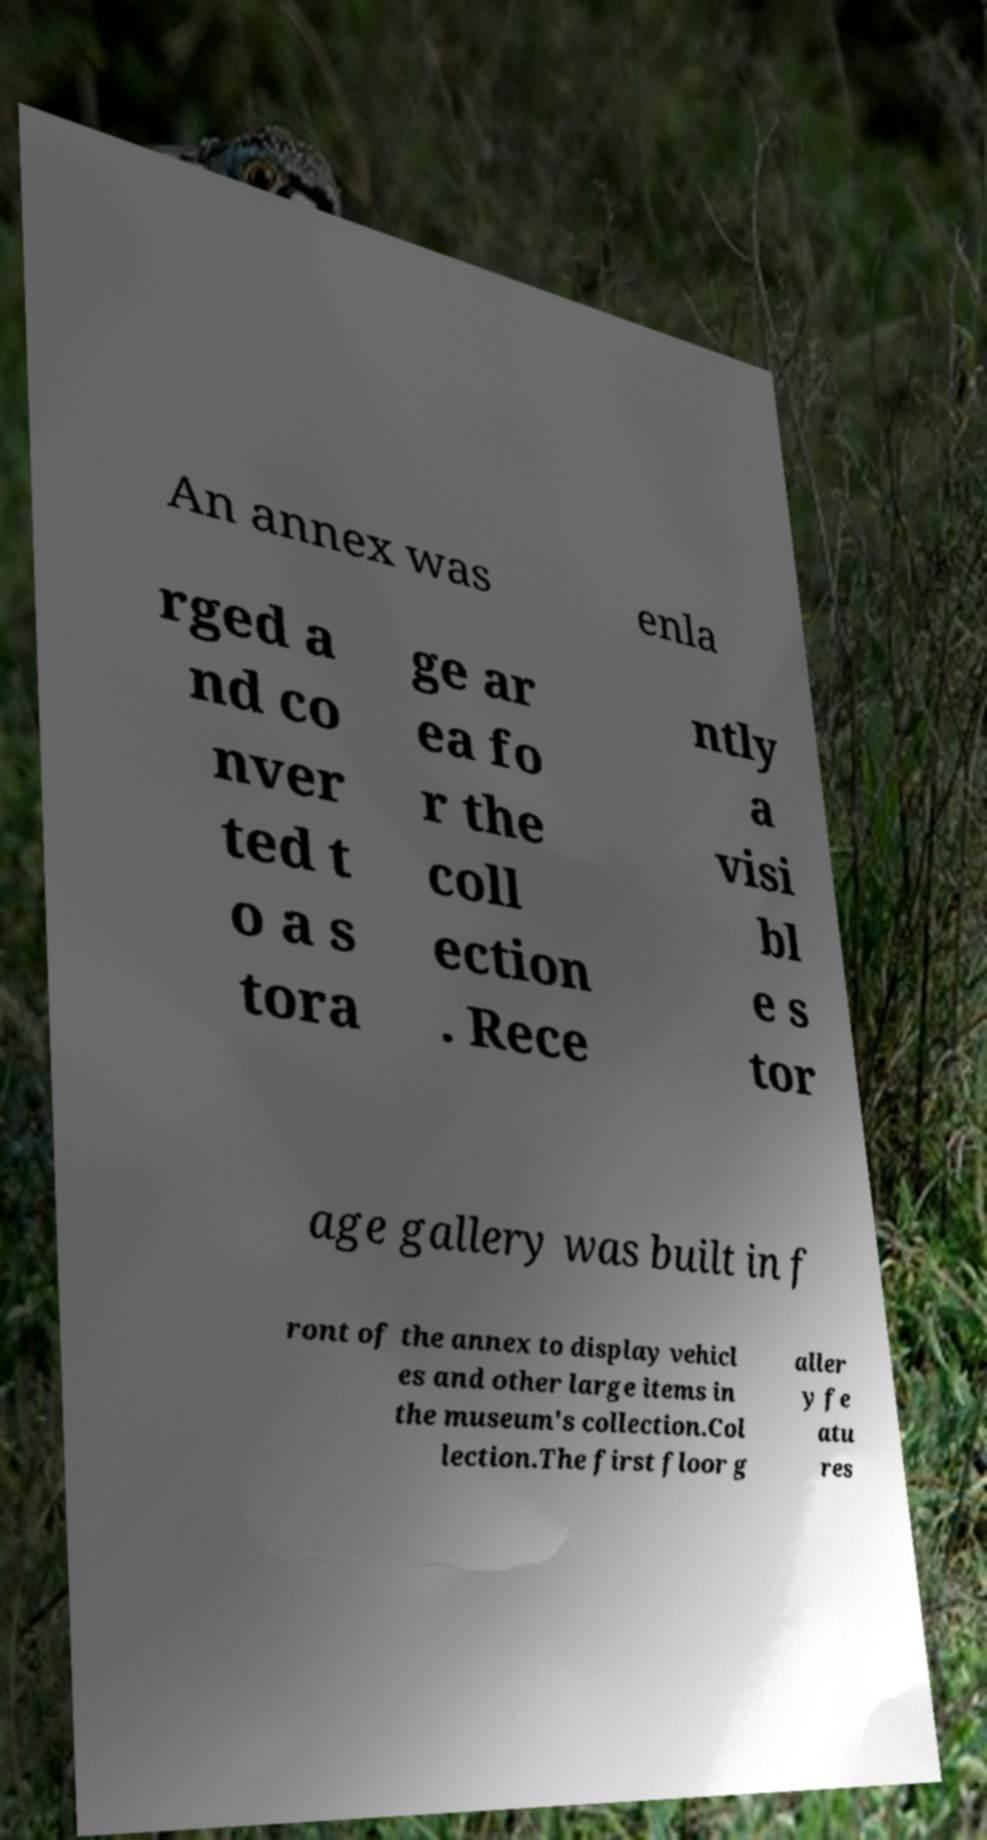There's text embedded in this image that I need extracted. Can you transcribe it verbatim? An annex was enla rged a nd co nver ted t o a s tora ge ar ea fo r the coll ection . Rece ntly a visi bl e s tor age gallery was built in f ront of the annex to display vehicl es and other large items in the museum's collection.Col lection.The first floor g aller y fe atu res 